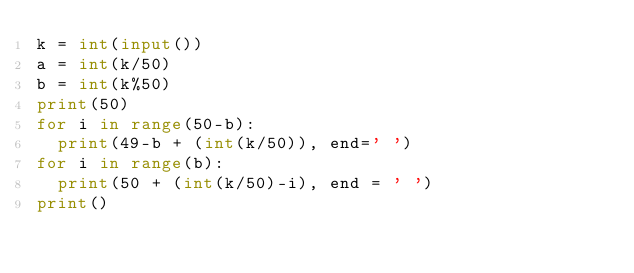Convert code to text. <code><loc_0><loc_0><loc_500><loc_500><_Python_>k = int(input())
a = int(k/50) 
b = int(k%50) 
print(50)
for i in range(50-b):
	print(49-b + (int(k/50)), end=' ') 
for i in range(b):
	print(50 + (int(k/50)-i), end = ' ')
print()
</code> 